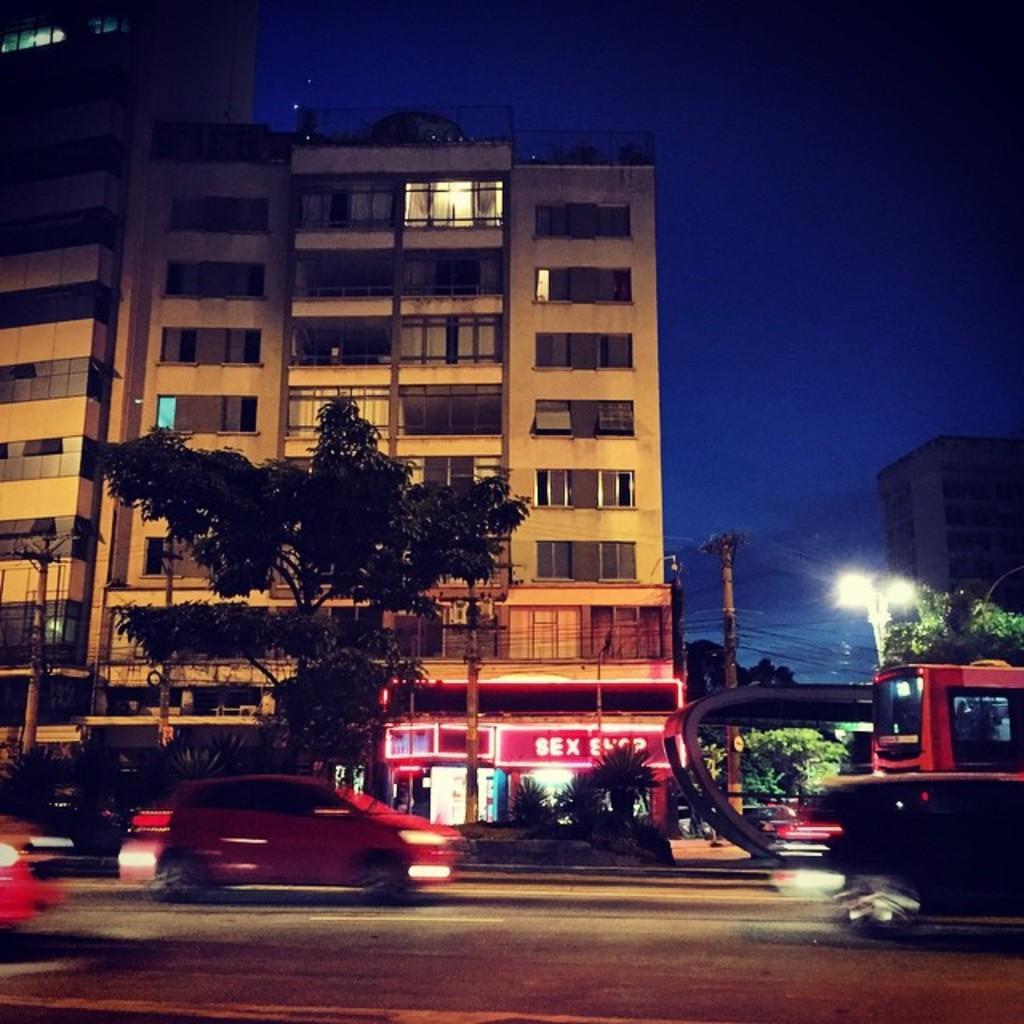In one or two sentences, can you explain what this image depicts? In this image there are vehicles on the road. At the back side there are trees, buildings, street lights, utility poles and at the top there is sky. 